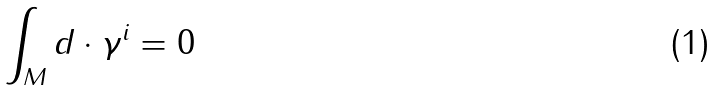<formula> <loc_0><loc_0><loc_500><loc_500>\int _ { M } d \cdot \gamma ^ { i } = 0</formula> 